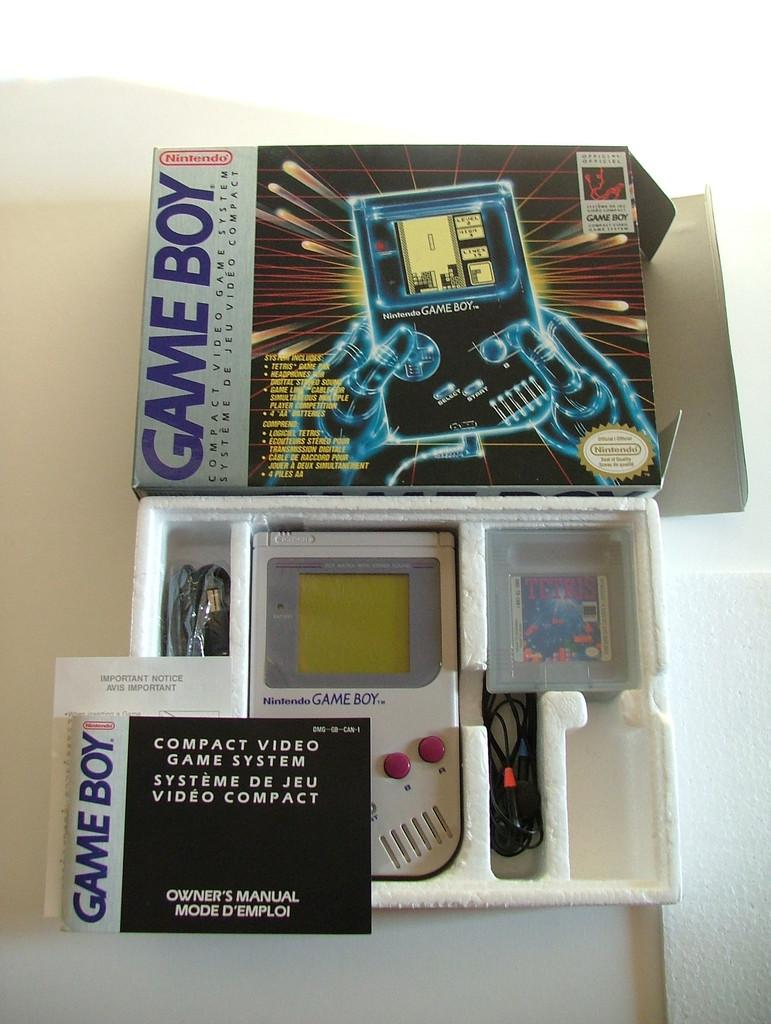<image>
Write a terse but informative summary of the picture. an open box that is labeled as a GAME BOY 